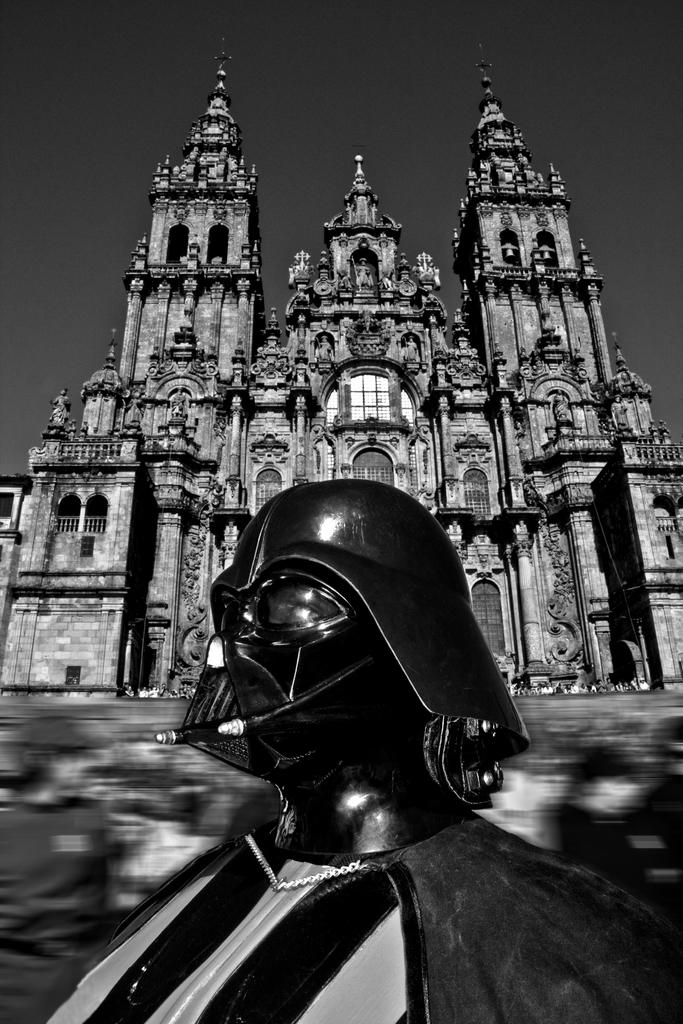What is the main subject of the image? There is a black object in the image. What can be seen in the background of the image? There is a building and the sky visible in the background of the image. What is the color scheme of the image? The image is black and white in color. Where are the cherries located in the image? There are no cherries present in the image. Can you tell me how the father and mother are interacting in the image? There is no father or mother present in the image. 